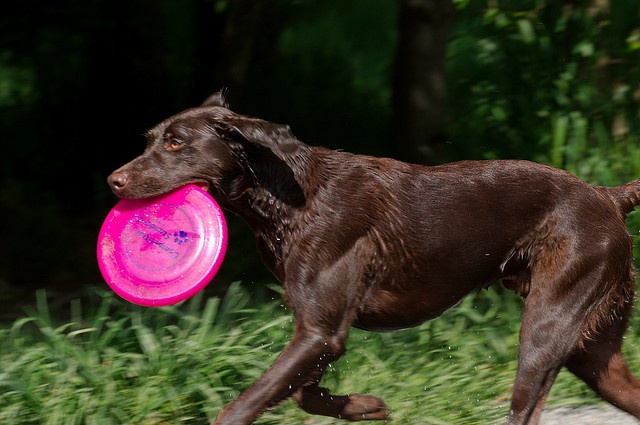Describe the objects in this image and their specific colors. I can see dog in black, maroon, and gray tones and frisbee in black, violet, and magenta tones in this image. 